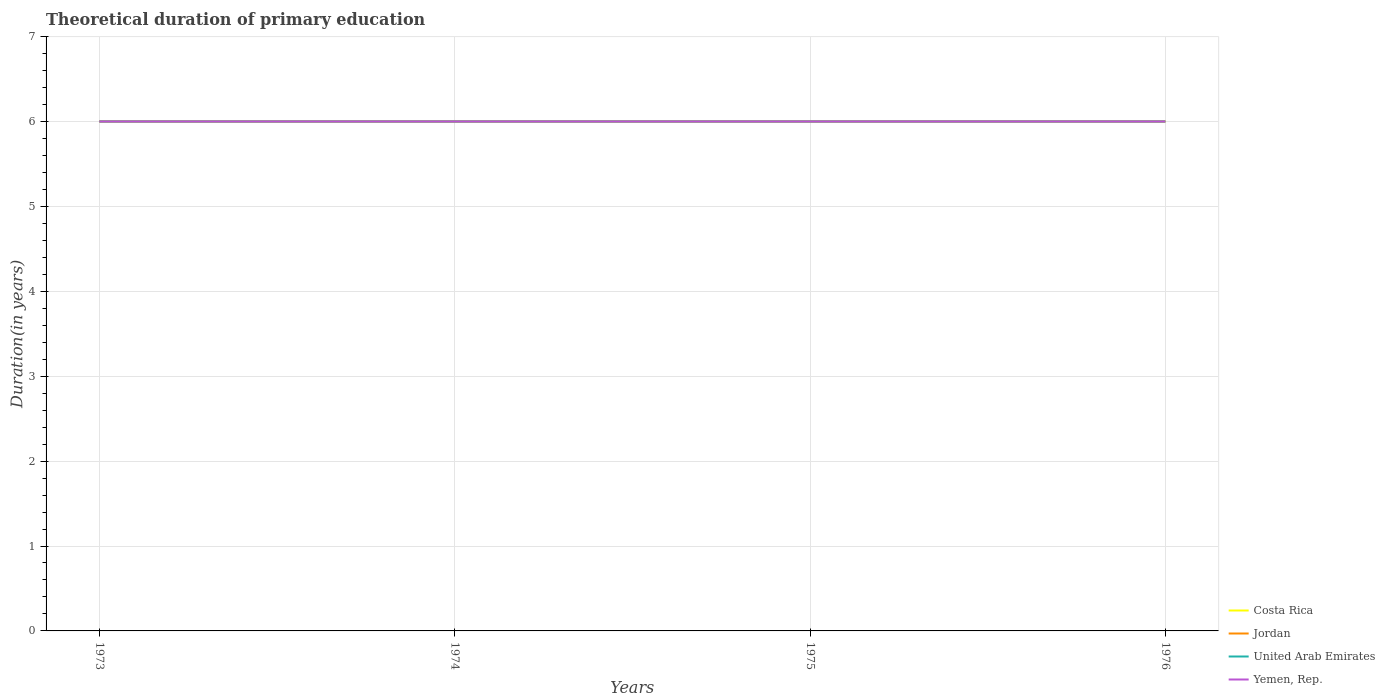How many different coloured lines are there?
Offer a very short reply. 4. Does the line corresponding to Yemen, Rep. intersect with the line corresponding to Costa Rica?
Offer a terse response. Yes. Across all years, what is the maximum total theoretical duration of primary education in United Arab Emirates?
Make the answer very short. 6. What is the total total theoretical duration of primary education in Jordan in the graph?
Provide a succinct answer. 0. What is the difference between the highest and the second highest total theoretical duration of primary education in United Arab Emirates?
Provide a succinct answer. 0. What is the difference between the highest and the lowest total theoretical duration of primary education in Jordan?
Offer a terse response. 0. Is the total theoretical duration of primary education in Yemen, Rep. strictly greater than the total theoretical duration of primary education in Jordan over the years?
Your answer should be very brief. No. Does the graph contain grids?
Give a very brief answer. Yes. How many legend labels are there?
Provide a short and direct response. 4. What is the title of the graph?
Ensure brevity in your answer.  Theoretical duration of primary education. What is the label or title of the Y-axis?
Your answer should be very brief. Duration(in years). What is the Duration(in years) of Costa Rica in 1973?
Make the answer very short. 6. What is the Duration(in years) of United Arab Emirates in 1973?
Provide a succinct answer. 6. What is the Duration(in years) of Jordan in 1975?
Give a very brief answer. 6. What is the Duration(in years) of United Arab Emirates in 1975?
Offer a very short reply. 6. What is the Duration(in years) of Costa Rica in 1976?
Your answer should be very brief. 6. Across all years, what is the maximum Duration(in years) of Costa Rica?
Your answer should be very brief. 6. Across all years, what is the maximum Duration(in years) in Jordan?
Keep it short and to the point. 6. Across all years, what is the maximum Duration(in years) of Yemen, Rep.?
Make the answer very short. 6. Across all years, what is the minimum Duration(in years) of Yemen, Rep.?
Ensure brevity in your answer.  6. What is the total Duration(in years) in Yemen, Rep. in the graph?
Offer a terse response. 24. What is the difference between the Duration(in years) in Costa Rica in 1973 and that in 1974?
Ensure brevity in your answer.  0. What is the difference between the Duration(in years) in Jordan in 1973 and that in 1974?
Ensure brevity in your answer.  0. What is the difference between the Duration(in years) in Yemen, Rep. in 1973 and that in 1974?
Give a very brief answer. 0. What is the difference between the Duration(in years) in Costa Rica in 1973 and that in 1975?
Offer a terse response. 0. What is the difference between the Duration(in years) of United Arab Emirates in 1973 and that in 1975?
Provide a short and direct response. 0. What is the difference between the Duration(in years) in Costa Rica in 1973 and that in 1976?
Give a very brief answer. 0. What is the difference between the Duration(in years) of Jordan in 1973 and that in 1976?
Make the answer very short. 0. What is the difference between the Duration(in years) of Yemen, Rep. in 1973 and that in 1976?
Ensure brevity in your answer.  0. What is the difference between the Duration(in years) of Costa Rica in 1974 and that in 1975?
Make the answer very short. 0. What is the difference between the Duration(in years) of United Arab Emirates in 1974 and that in 1975?
Offer a terse response. 0. What is the difference between the Duration(in years) of Yemen, Rep. in 1974 and that in 1975?
Give a very brief answer. 0. What is the difference between the Duration(in years) in Costa Rica in 1974 and that in 1976?
Make the answer very short. 0. What is the difference between the Duration(in years) in Costa Rica in 1973 and the Duration(in years) in United Arab Emirates in 1974?
Offer a very short reply. 0. What is the difference between the Duration(in years) of Costa Rica in 1973 and the Duration(in years) of Yemen, Rep. in 1974?
Provide a succinct answer. 0. What is the difference between the Duration(in years) in United Arab Emirates in 1973 and the Duration(in years) in Yemen, Rep. in 1974?
Offer a terse response. 0. What is the difference between the Duration(in years) in Costa Rica in 1973 and the Duration(in years) in Yemen, Rep. in 1975?
Your response must be concise. 0. What is the difference between the Duration(in years) of Jordan in 1973 and the Duration(in years) of United Arab Emirates in 1975?
Ensure brevity in your answer.  0. What is the difference between the Duration(in years) in Jordan in 1973 and the Duration(in years) in Yemen, Rep. in 1975?
Your response must be concise. 0. What is the difference between the Duration(in years) in Costa Rica in 1973 and the Duration(in years) in Yemen, Rep. in 1976?
Make the answer very short. 0. What is the difference between the Duration(in years) in Jordan in 1973 and the Duration(in years) in United Arab Emirates in 1976?
Your response must be concise. 0. What is the difference between the Duration(in years) of Jordan in 1973 and the Duration(in years) of Yemen, Rep. in 1976?
Provide a succinct answer. 0. What is the difference between the Duration(in years) of Costa Rica in 1974 and the Duration(in years) of Jordan in 1975?
Your answer should be very brief. 0. What is the difference between the Duration(in years) in Jordan in 1974 and the Duration(in years) in Yemen, Rep. in 1975?
Ensure brevity in your answer.  0. What is the difference between the Duration(in years) of Costa Rica in 1974 and the Duration(in years) of Jordan in 1976?
Ensure brevity in your answer.  0. What is the difference between the Duration(in years) in Costa Rica in 1974 and the Duration(in years) in United Arab Emirates in 1976?
Offer a terse response. 0. What is the difference between the Duration(in years) of United Arab Emirates in 1974 and the Duration(in years) of Yemen, Rep. in 1976?
Your response must be concise. 0. What is the difference between the Duration(in years) of Jordan in 1975 and the Duration(in years) of United Arab Emirates in 1976?
Offer a very short reply. 0. What is the difference between the Duration(in years) in Jordan in 1975 and the Duration(in years) in Yemen, Rep. in 1976?
Provide a succinct answer. 0. What is the average Duration(in years) of United Arab Emirates per year?
Make the answer very short. 6. In the year 1973, what is the difference between the Duration(in years) of Costa Rica and Duration(in years) of Yemen, Rep.?
Ensure brevity in your answer.  0. In the year 1974, what is the difference between the Duration(in years) in Jordan and Duration(in years) in Yemen, Rep.?
Provide a short and direct response. 0. In the year 1974, what is the difference between the Duration(in years) in United Arab Emirates and Duration(in years) in Yemen, Rep.?
Provide a short and direct response. 0. In the year 1975, what is the difference between the Duration(in years) of Costa Rica and Duration(in years) of Jordan?
Give a very brief answer. 0. In the year 1975, what is the difference between the Duration(in years) of Costa Rica and Duration(in years) of United Arab Emirates?
Give a very brief answer. 0. In the year 1975, what is the difference between the Duration(in years) of Costa Rica and Duration(in years) of Yemen, Rep.?
Keep it short and to the point. 0. In the year 1975, what is the difference between the Duration(in years) in Jordan and Duration(in years) in Yemen, Rep.?
Your answer should be compact. 0. In the year 1976, what is the difference between the Duration(in years) in Costa Rica and Duration(in years) in Yemen, Rep.?
Give a very brief answer. 0. In the year 1976, what is the difference between the Duration(in years) of Jordan and Duration(in years) of United Arab Emirates?
Give a very brief answer. 0. In the year 1976, what is the difference between the Duration(in years) of United Arab Emirates and Duration(in years) of Yemen, Rep.?
Your answer should be compact. 0. What is the ratio of the Duration(in years) of Costa Rica in 1973 to that in 1974?
Give a very brief answer. 1. What is the ratio of the Duration(in years) of United Arab Emirates in 1973 to that in 1974?
Make the answer very short. 1. What is the ratio of the Duration(in years) in Yemen, Rep. in 1973 to that in 1974?
Provide a succinct answer. 1. What is the ratio of the Duration(in years) of Costa Rica in 1973 to that in 1975?
Your response must be concise. 1. What is the ratio of the Duration(in years) in Jordan in 1973 to that in 1975?
Give a very brief answer. 1. What is the ratio of the Duration(in years) in Yemen, Rep. in 1973 to that in 1975?
Give a very brief answer. 1. What is the ratio of the Duration(in years) in Costa Rica in 1973 to that in 1976?
Give a very brief answer. 1. What is the ratio of the Duration(in years) in United Arab Emirates in 1973 to that in 1976?
Ensure brevity in your answer.  1. What is the ratio of the Duration(in years) in Yemen, Rep. in 1973 to that in 1976?
Provide a succinct answer. 1. What is the ratio of the Duration(in years) of United Arab Emirates in 1974 to that in 1975?
Ensure brevity in your answer.  1. What is the ratio of the Duration(in years) of Yemen, Rep. in 1974 to that in 1975?
Keep it short and to the point. 1. What is the ratio of the Duration(in years) in Jordan in 1974 to that in 1976?
Provide a short and direct response. 1. What is the ratio of the Duration(in years) of United Arab Emirates in 1974 to that in 1976?
Offer a very short reply. 1. What is the ratio of the Duration(in years) of Jordan in 1975 to that in 1976?
Your response must be concise. 1. What is the difference between the highest and the second highest Duration(in years) of Jordan?
Your answer should be compact. 0. What is the difference between the highest and the lowest Duration(in years) in Jordan?
Your answer should be compact. 0. What is the difference between the highest and the lowest Duration(in years) in United Arab Emirates?
Give a very brief answer. 0. 